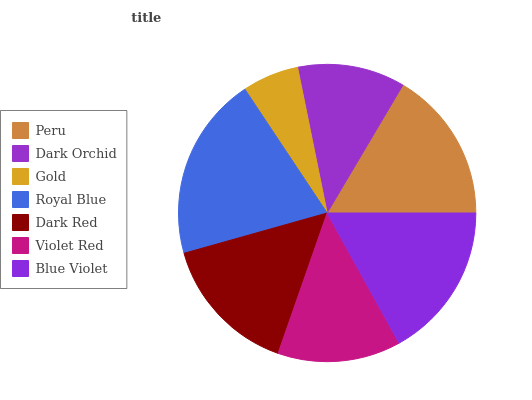Is Gold the minimum?
Answer yes or no. Yes. Is Royal Blue the maximum?
Answer yes or no. Yes. Is Dark Orchid the minimum?
Answer yes or no. No. Is Dark Orchid the maximum?
Answer yes or no. No. Is Peru greater than Dark Orchid?
Answer yes or no. Yes. Is Dark Orchid less than Peru?
Answer yes or no. Yes. Is Dark Orchid greater than Peru?
Answer yes or no. No. Is Peru less than Dark Orchid?
Answer yes or no. No. Is Dark Red the high median?
Answer yes or no. Yes. Is Dark Red the low median?
Answer yes or no. Yes. Is Dark Orchid the high median?
Answer yes or no. No. Is Royal Blue the low median?
Answer yes or no. No. 